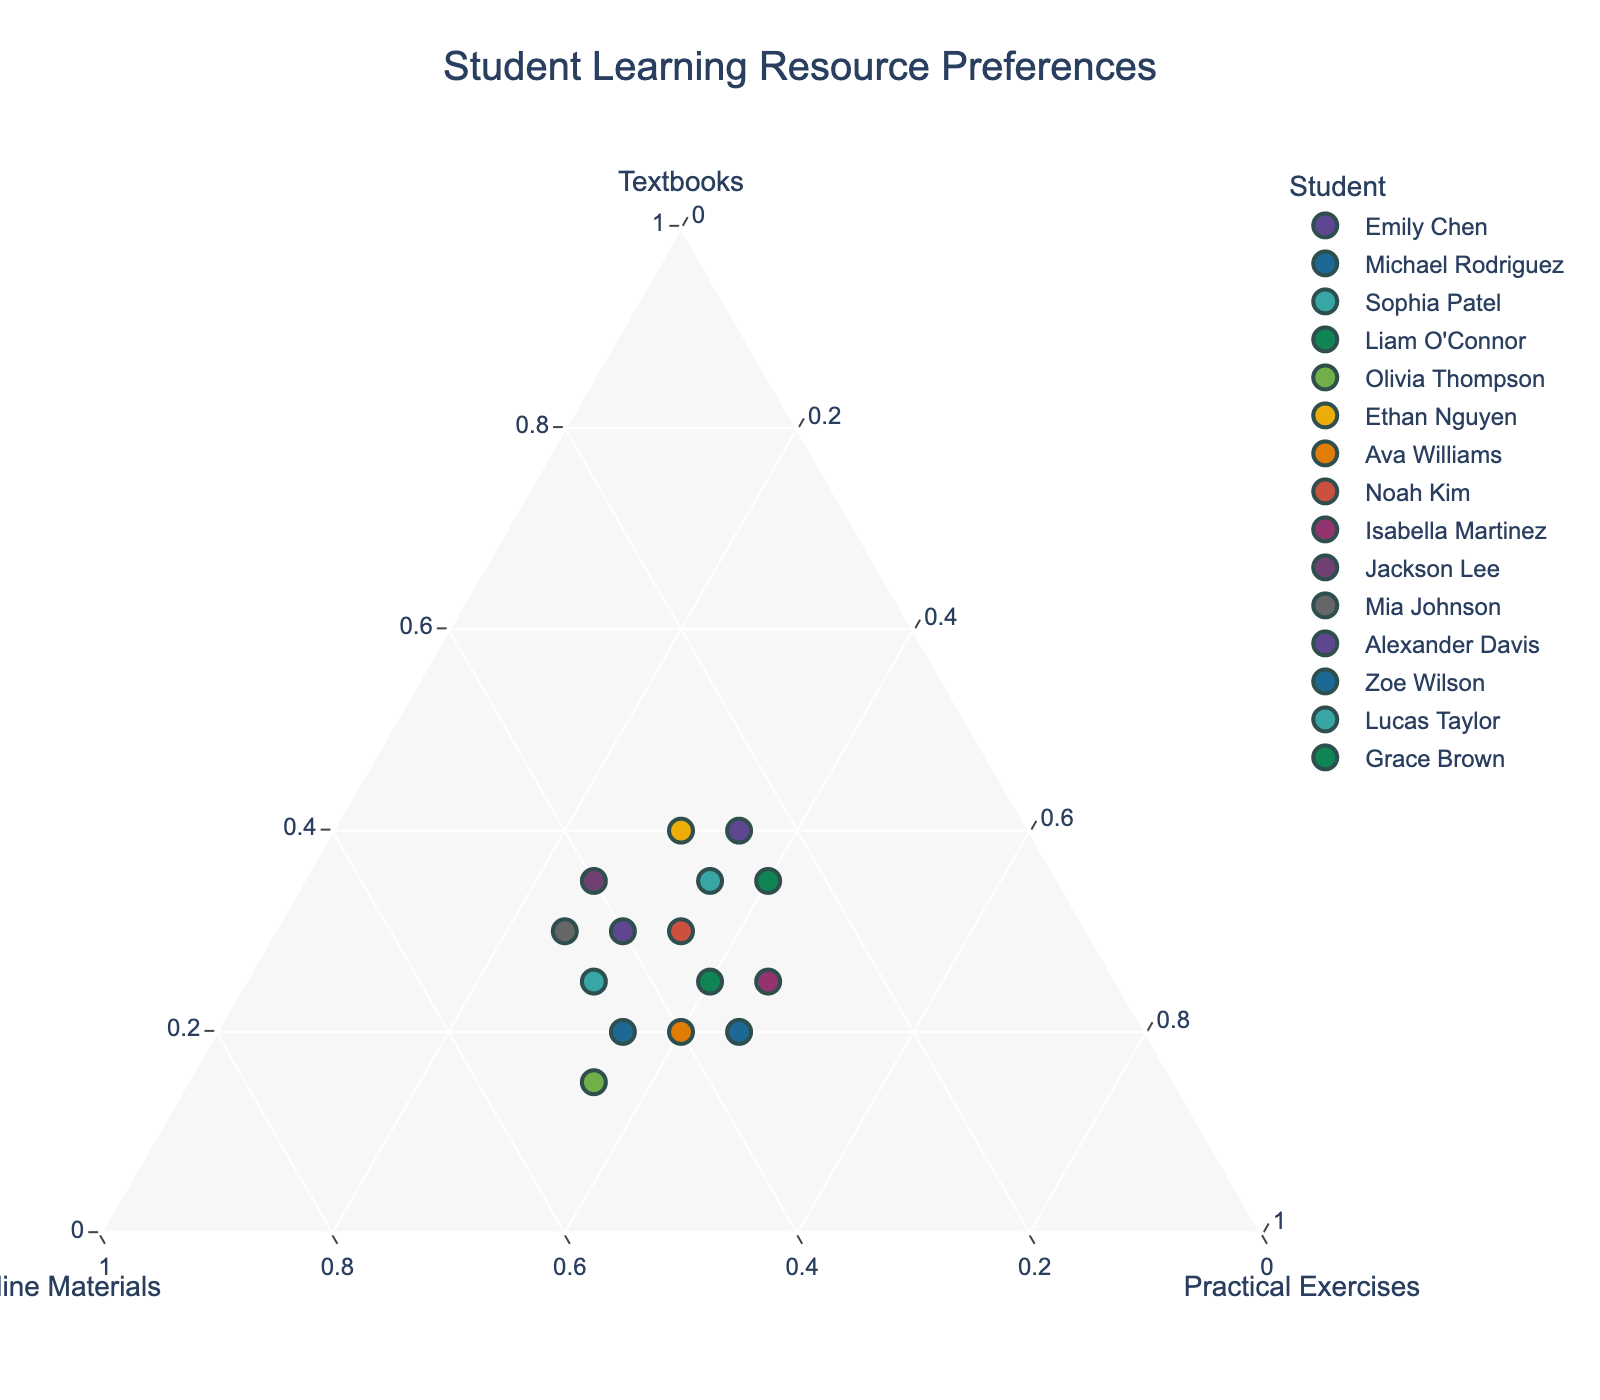who prefers practical exercises the most? To find who prefers practical exercises the most, look at the vertex labeled "Practical Exercises" and see who is closest to that point. Isabella Martinez and Michael Rodriguez both have the highest preference ratio for practical exercises (45%).
Answer: Isabella Martinez and Michael Rodriguez which student has the highest preference for textbooks? To identify the student with the highest preference for textbooks, look at the vertex labeled "Textbooks" and see who has the highest percentage. Both Ethan Nguyen and Alexander Davis show the highest preference for textbooks (40%).
Answer: Ethan Nguyen and Alexander Davis how does Olivia Thompson's preference distribution compare with Ava Williams'? To compare Olivia Thompson and Ava Williams, check their positions relative to each vertex. Olivia has 15% for textbooks, 50% for online materials, and 35% for practical exercises. Ava has 20% for textbooks, 40% for online materials, and 40% for practical exercises.
Answer: Olivia prefers more online materials, Ava prefers more practical exercises, textbooks are close who has a balanced preference among the three resources? Look for a student whose point is near the center of the ternary plot, indicating a balanced preference among textbooks, online materials, and practical exercises. No student has exactly equal preference, but Emily Chen, Jackson Lee, Noah Kim, and Lucas Taylor have close preferences in each dimension.
Answer: Emily Chen, Jackson Lee, Noah Kim, Lucas Taylor what is the average preference for online materials across the students? Sum up the normalized percentages for "Online Materials" for all students and divide by the total number of students (15). For instance, (40 + 35 + 45 + 25 + 50 + 30 + 40 + 35 + 30 + 40 + 45 + 25 + 45 + 30 + 35) / 15.
Answer: 36.7% do any students have an equal preference for all three resources? Check if any student has their normalized percentages equally distributed across all three vertices (i.e., approximately 33.3% each). None of the students have exactly equal preferences.
Answer: No what is the range of preferences for practical exercises? To find the range of preferences for practical exercises, identify the minimum and maximum normalized percentages. The minimum is 25% (Jackson Lee, Mia Johnson), and the maximum is 45% (Michael Rodriguez, Isabella Martinez, Grace Brown).
Answer: 25% to 45% who prefers textbooks more than online materials but less than practical exercises? Compare the percentages of each student: Textbooks should be more than online materials but less than practical exercises. Michael Rodriguez fits this pattern (20% textbooks > 35% online materials < 45% practical exercises).
Answer: Michael Rodriguez 